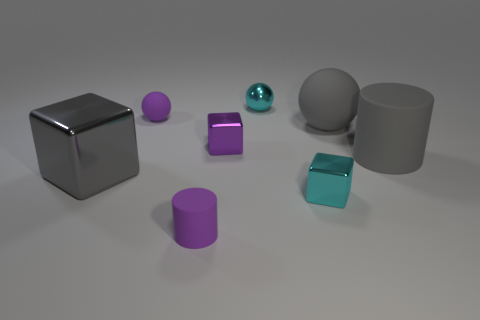What number of other things are the same shape as the big gray metallic thing? There are three objects that share the same cylindrical shape as the large gray metallic cylinder: one smaller purple cylinder, one smaller greenish-blue cylinder, and one more small gray cylinder. 